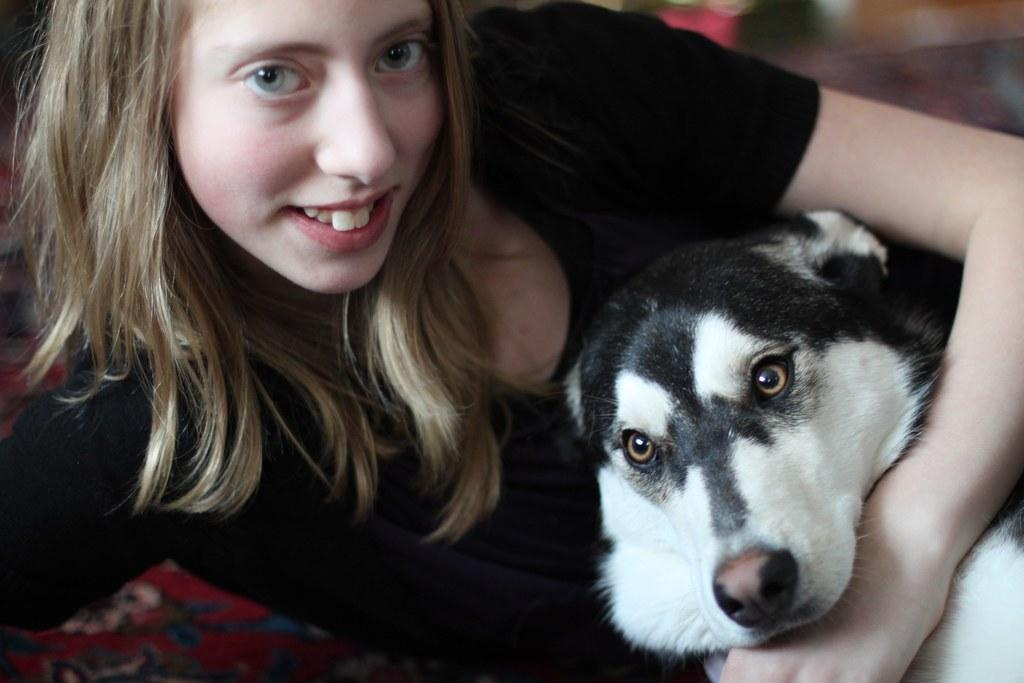Who is present in the image? There is a woman in the image. What is the woman wearing? The woman is wearing a black t-shirt. What is the woman holding in the image? The woman is holding a white dog. What expression does the woman have? The woman is smiling. What type of stamp can be seen on the woman's forehead in the image? There is no stamp present on the woman's forehead in the image. 